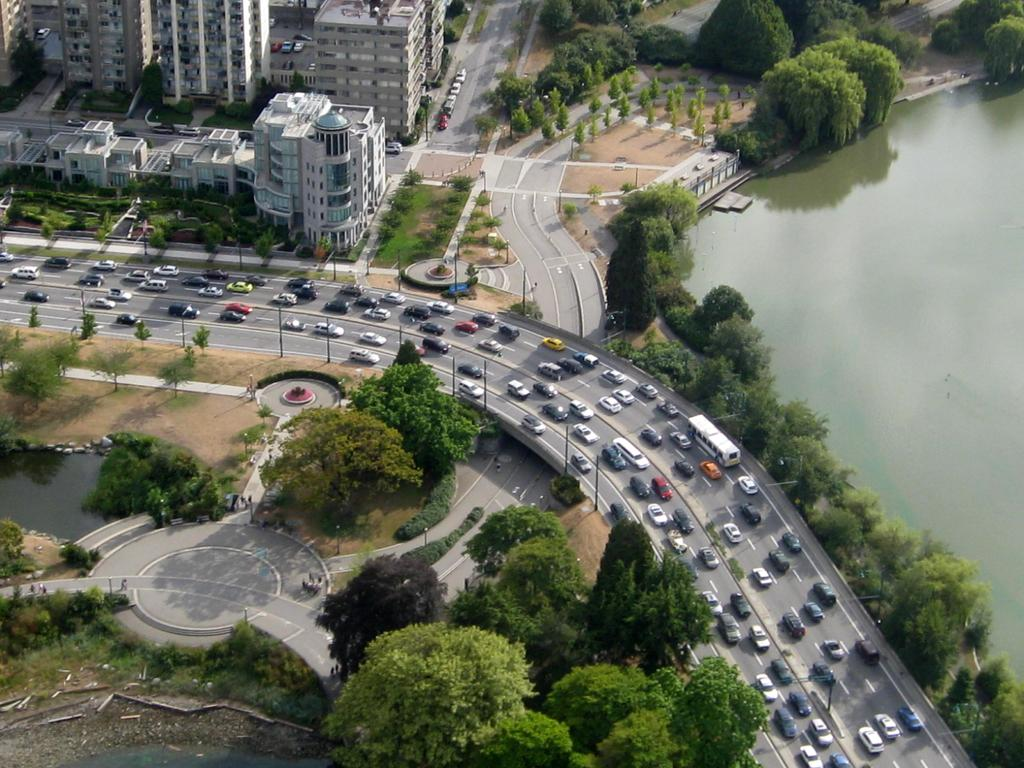What type of view is shown in the image? The image is an aerial view. What natural elements can be seen in the image? There are trees visible in the image. What man-made structures are present in the image? Tower buildings are present in the image. What is the purpose of the vehicles moving on the road in the image? The vehicles are likely moving for transportation purposes. What body of water is visible in the image? There is water visible in the image. What type of soup is being served in the image? There is no soup present in the image; it is an aerial view of a landscape with trees, tower buildings, and water. 